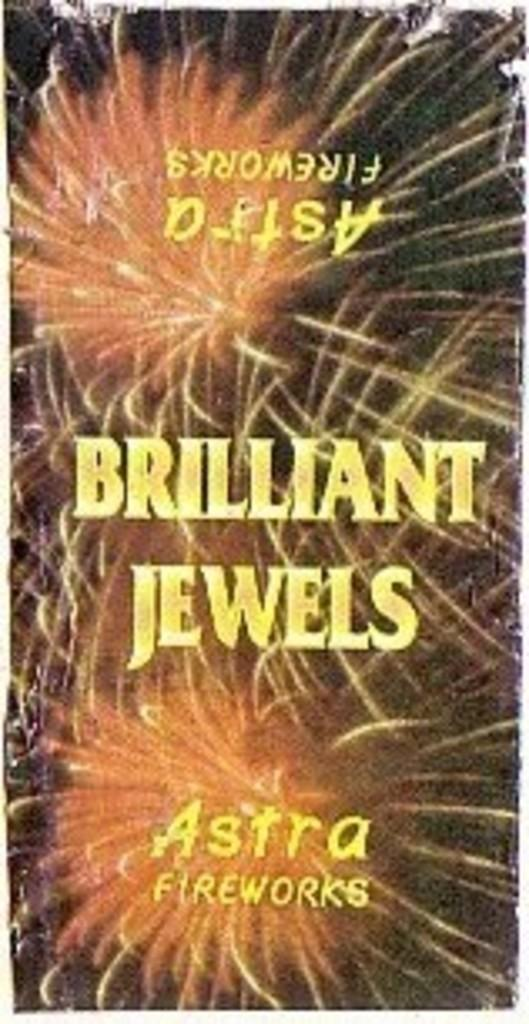<image>
Summarize the visual content of the image. A book cover with fireworks that says Brilliant Jewels. 